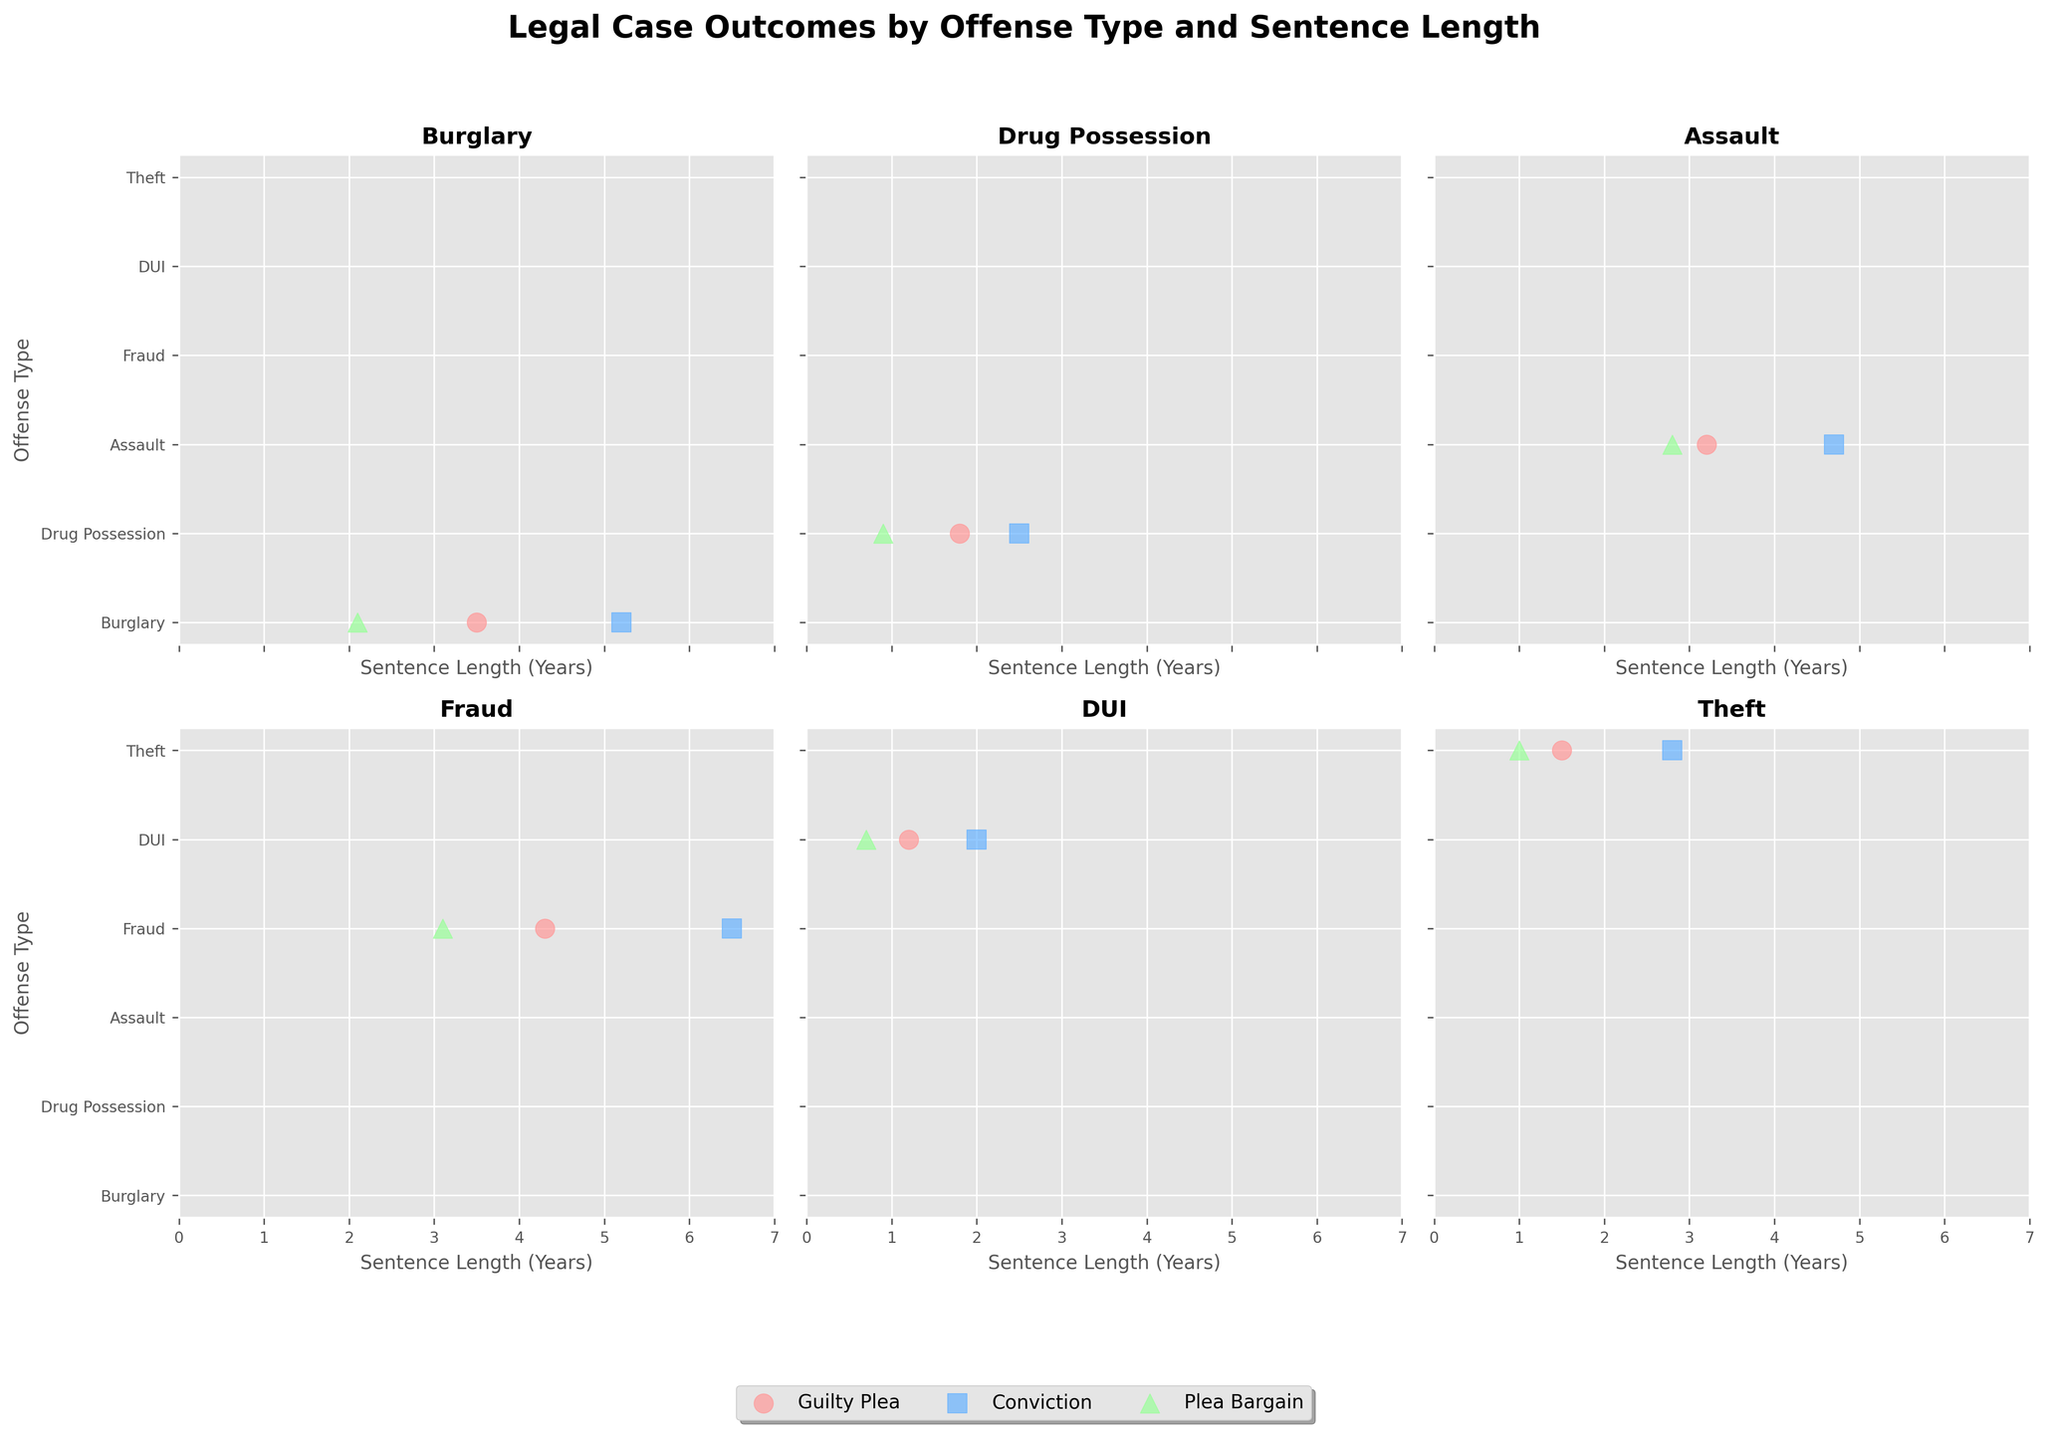How many offense types are represented in the figure? The figure shows six subplots, each representing a different offense type. These offense types are Burglary, Drug Possession, Assault, Fraud, DUI, and Theft.
Answer: Six What is the title of the figure? The title of the figure is located at the top and reads: "Legal Case Outcomes by Offense Type and Sentence Length".
Answer: Legal Case Outcomes by Offense Type and Sentence Length Which offense type has the longest sentence length for a Conviction? By examining the subplot titles and sentence lengths for Convictions, it is clear that Fraud has the longest sentence length, at 6.5 years.
Answer: Fraud In the DUI subplot, which case outcome has the shortest sentence length? In the DUI subplot, the shortest sentence length is associated with the Plea Bargain outcome, which is 0.7 years.
Answer: Plea Bargain What colors are used to represent the different case outcomes? The colors representing the case outcomes are: Guilty Plea in light red, Conviction in light blue, and Plea Bargain in light green.
Answer: Light red, light blue, light green How many data points fall under the Guilty Plea outcome for Assault? In the Assault subplot, there is one data point that falls under the Guilty Plea outcome.
Answer: One What is the average sentence length for Drug Possession cases? The sentence lengths for Drug Possession cases are 1.8, 2.5, and 0.9 years. The average is calculated as (1.8 + 2.5 + 0.9) / 3 = 1.73 years.
Answer: 1.73 years Compare the sentence lengths between the Conviction outcomes for Burglary and Theft. Which one is longer? The sentence length for a Conviction in Burglary is 5.2 years, whereas for Theft, it is 2.8 years. Therefore, the Burglary Conviction sentence is longer.
Answer: Burglary Which offense type witnessed a sentence length over 5 years under a Guilty Plea outcome? By examining the subplots and the sentence lengths for Guilty Plea outcomes, no offense type has a Guilty Plea with a sentence length over 5 years.
Answer: None Are there any offense types where the sentence length for Guilty Plea is higher than the sentence length for Conviction? Reviewing the sentence lengths across all offense types, there is no instance where the sentence length for Guilty Plea is higher than for Conviction.
Answer: No 